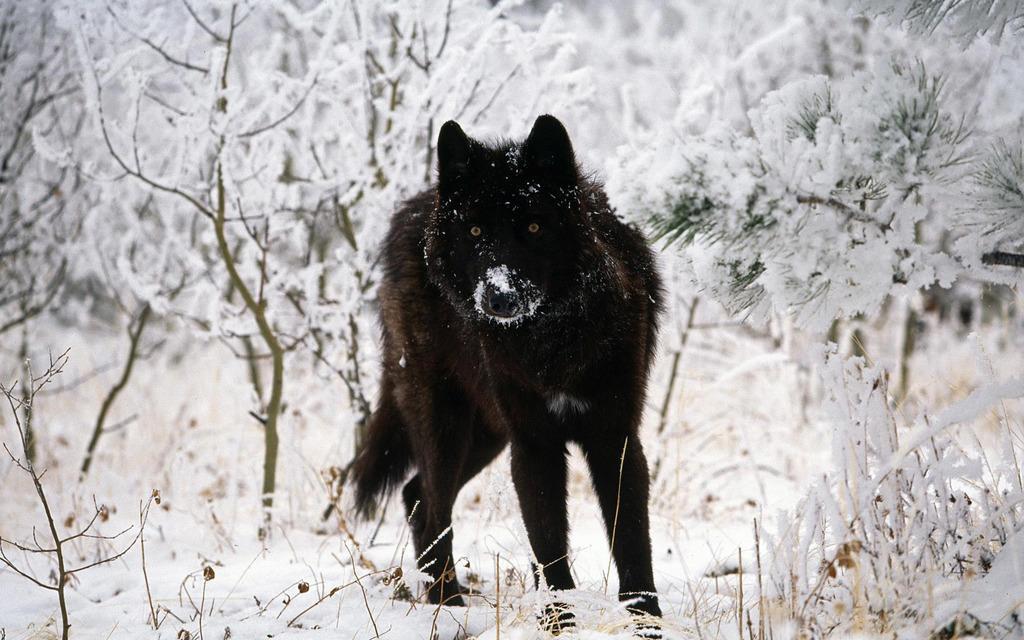Describe this image in one or two sentences. In this image we can see an animal's, snow, plants, and trees. 